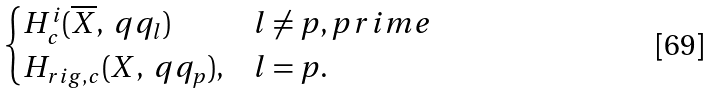Convert formula to latex. <formula><loc_0><loc_0><loc_500><loc_500>\begin{cases} H _ { c } ^ { i } ( \overline { X } , \ q q _ { l } ) & l \neq p , p r i m e \\ H _ { r i g , c } ( X , \ q q _ { p } ) , & l = p . \end{cases}</formula> 